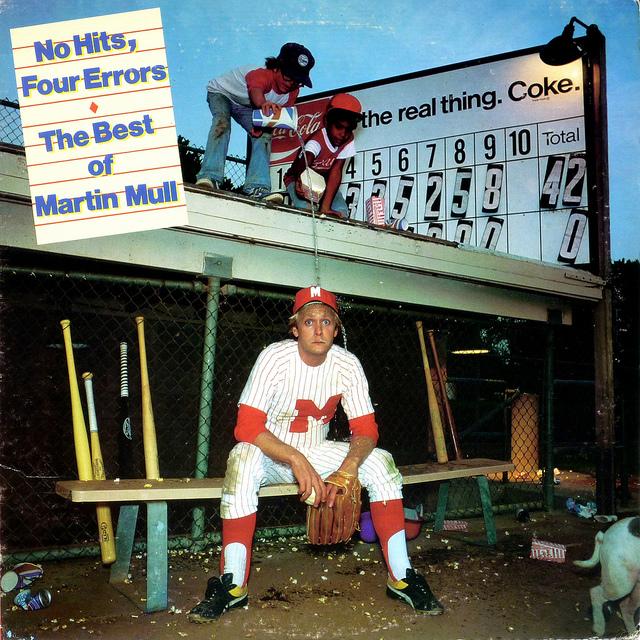Has this dog had training?
Answer briefly. No. What are the boys on the roof doing?
Give a very brief answer. Pouring water. What is the guy about to catch?
Answer briefly. Ball. What letter is on his uniform?
Write a very short answer. M. Where are the kids?
Concise answer only. On top of dugout. 